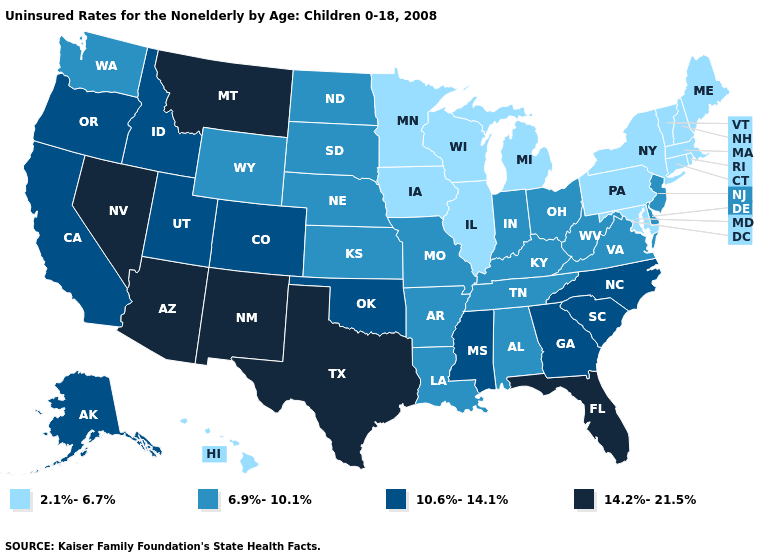What is the value of Ohio?
Write a very short answer. 6.9%-10.1%. What is the value of Kentucky?
Short answer required. 6.9%-10.1%. Does Louisiana have a higher value than Arkansas?
Concise answer only. No. Does the map have missing data?
Answer briefly. No. Does the map have missing data?
Answer briefly. No. Name the states that have a value in the range 14.2%-21.5%?
Be succinct. Arizona, Florida, Montana, Nevada, New Mexico, Texas. Does Rhode Island have the highest value in the USA?
Keep it brief. No. What is the value of New Mexico?
Concise answer only. 14.2%-21.5%. Name the states that have a value in the range 10.6%-14.1%?
Quick response, please. Alaska, California, Colorado, Georgia, Idaho, Mississippi, North Carolina, Oklahoma, Oregon, South Carolina, Utah. What is the value of Vermont?
Write a very short answer. 2.1%-6.7%. Which states have the lowest value in the USA?
Short answer required. Connecticut, Hawaii, Illinois, Iowa, Maine, Maryland, Massachusetts, Michigan, Minnesota, New Hampshire, New York, Pennsylvania, Rhode Island, Vermont, Wisconsin. What is the value of Missouri?
Write a very short answer. 6.9%-10.1%. What is the value of Nebraska?
Keep it brief. 6.9%-10.1%. What is the value of Arkansas?
Concise answer only. 6.9%-10.1%. Does North Dakota have the same value as West Virginia?
Short answer required. Yes. 